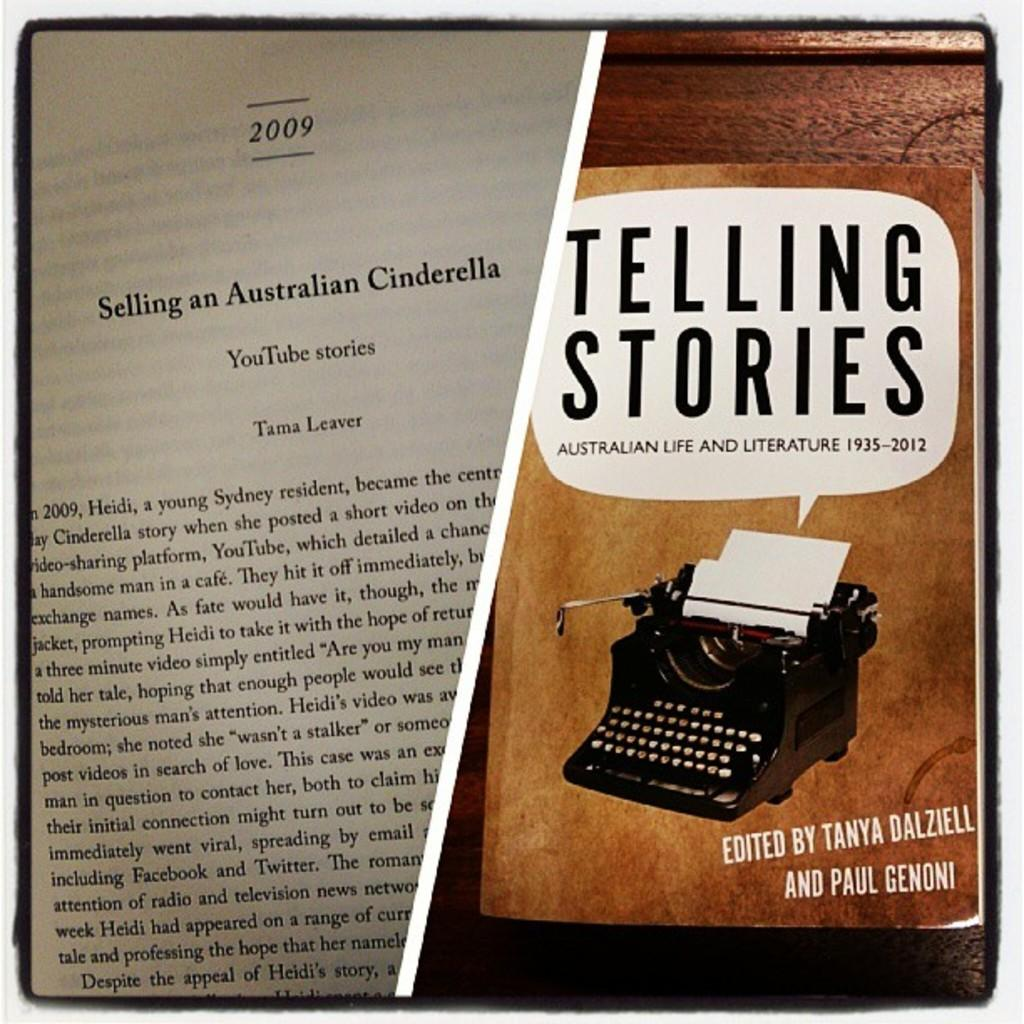Provide a one-sentence caption for the provided image. A typewriter is on the cover of a book titled Telling Stories. 